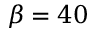Convert formula to latex. <formula><loc_0><loc_0><loc_500><loc_500>\beta = 4 0</formula> 